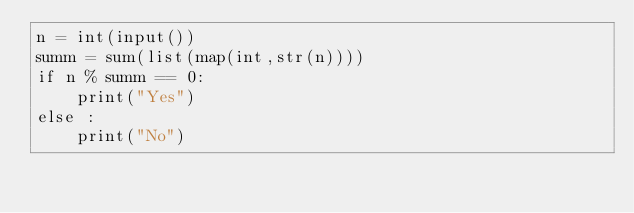Convert code to text. <code><loc_0><loc_0><loc_500><loc_500><_Python_>n = int(input())
summ = sum(list(map(int,str(n))))
if n % summ == 0:
    print("Yes")
else :
    print("No")</code> 